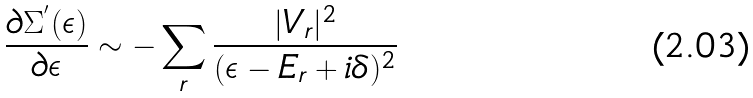Convert formula to latex. <formula><loc_0><loc_0><loc_500><loc_500>\frac { \partial \Sigma ^ { ^ { \prime } } ( \epsilon ) } { \partial \epsilon } \sim - \sum _ { r } \frac { | V _ { r } | ^ { 2 } } { ( \epsilon - E _ { r } + i \delta ) ^ { 2 } }</formula> 